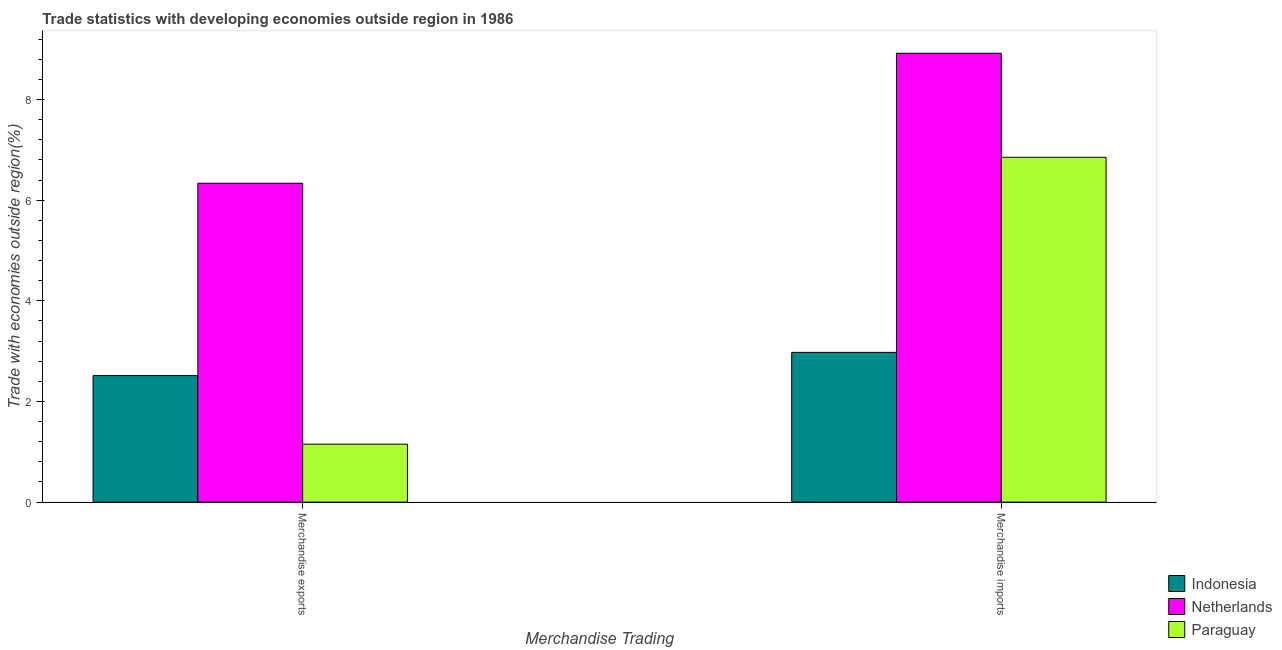How many different coloured bars are there?
Provide a succinct answer. 3. How many groups of bars are there?
Provide a succinct answer. 2. Are the number of bars on each tick of the X-axis equal?
Give a very brief answer. Yes. How many bars are there on the 2nd tick from the left?
Keep it short and to the point. 3. What is the label of the 1st group of bars from the left?
Ensure brevity in your answer.  Merchandise exports. What is the merchandise exports in Paraguay?
Your response must be concise. 1.15. Across all countries, what is the maximum merchandise exports?
Offer a terse response. 6.34. Across all countries, what is the minimum merchandise imports?
Provide a short and direct response. 2.98. What is the total merchandise imports in the graph?
Give a very brief answer. 18.75. What is the difference between the merchandise imports in Paraguay and that in Indonesia?
Your answer should be compact. 3.88. What is the difference between the merchandise exports in Paraguay and the merchandise imports in Indonesia?
Keep it short and to the point. -1.82. What is the average merchandise exports per country?
Make the answer very short. 3.33. What is the difference between the merchandise imports and merchandise exports in Indonesia?
Keep it short and to the point. 0.46. What is the ratio of the merchandise imports in Paraguay to that in Netherlands?
Your answer should be very brief. 0.77. Is the merchandise exports in Netherlands less than that in Paraguay?
Offer a very short reply. No. What does the 3rd bar from the left in Merchandise exports represents?
Keep it short and to the point. Paraguay. What does the 3rd bar from the right in Merchandise imports represents?
Provide a succinct answer. Indonesia. Are all the bars in the graph horizontal?
Provide a succinct answer. No. Does the graph contain any zero values?
Your answer should be compact. No. Where does the legend appear in the graph?
Make the answer very short. Bottom right. What is the title of the graph?
Provide a succinct answer. Trade statistics with developing economies outside region in 1986. What is the label or title of the X-axis?
Provide a short and direct response. Merchandise Trading. What is the label or title of the Y-axis?
Your answer should be very brief. Trade with economies outside region(%). What is the Trade with economies outside region(%) of Indonesia in Merchandise exports?
Make the answer very short. 2.51. What is the Trade with economies outside region(%) in Netherlands in Merchandise exports?
Your response must be concise. 6.34. What is the Trade with economies outside region(%) in Paraguay in Merchandise exports?
Make the answer very short. 1.15. What is the Trade with economies outside region(%) of Indonesia in Merchandise imports?
Keep it short and to the point. 2.98. What is the Trade with economies outside region(%) of Netherlands in Merchandise imports?
Provide a short and direct response. 8.92. What is the Trade with economies outside region(%) of Paraguay in Merchandise imports?
Ensure brevity in your answer.  6.85. Across all Merchandise Trading, what is the maximum Trade with economies outside region(%) of Indonesia?
Your answer should be compact. 2.98. Across all Merchandise Trading, what is the maximum Trade with economies outside region(%) of Netherlands?
Offer a very short reply. 8.92. Across all Merchandise Trading, what is the maximum Trade with economies outside region(%) in Paraguay?
Ensure brevity in your answer.  6.85. Across all Merchandise Trading, what is the minimum Trade with economies outside region(%) of Indonesia?
Offer a terse response. 2.51. Across all Merchandise Trading, what is the minimum Trade with economies outside region(%) in Netherlands?
Keep it short and to the point. 6.34. Across all Merchandise Trading, what is the minimum Trade with economies outside region(%) of Paraguay?
Provide a short and direct response. 1.15. What is the total Trade with economies outside region(%) in Indonesia in the graph?
Provide a short and direct response. 5.49. What is the total Trade with economies outside region(%) in Netherlands in the graph?
Your answer should be compact. 15.25. What is the total Trade with economies outside region(%) of Paraguay in the graph?
Make the answer very short. 8. What is the difference between the Trade with economies outside region(%) in Indonesia in Merchandise exports and that in Merchandise imports?
Keep it short and to the point. -0.46. What is the difference between the Trade with economies outside region(%) of Netherlands in Merchandise exports and that in Merchandise imports?
Keep it short and to the point. -2.58. What is the difference between the Trade with economies outside region(%) of Paraguay in Merchandise exports and that in Merchandise imports?
Provide a succinct answer. -5.7. What is the difference between the Trade with economies outside region(%) in Indonesia in Merchandise exports and the Trade with economies outside region(%) in Netherlands in Merchandise imports?
Ensure brevity in your answer.  -6.4. What is the difference between the Trade with economies outside region(%) in Indonesia in Merchandise exports and the Trade with economies outside region(%) in Paraguay in Merchandise imports?
Your answer should be very brief. -4.34. What is the difference between the Trade with economies outside region(%) of Netherlands in Merchandise exports and the Trade with economies outside region(%) of Paraguay in Merchandise imports?
Make the answer very short. -0.52. What is the average Trade with economies outside region(%) in Indonesia per Merchandise Trading?
Make the answer very short. 2.74. What is the average Trade with economies outside region(%) of Netherlands per Merchandise Trading?
Your answer should be very brief. 7.63. What is the average Trade with economies outside region(%) in Paraguay per Merchandise Trading?
Ensure brevity in your answer.  4. What is the difference between the Trade with economies outside region(%) in Indonesia and Trade with economies outside region(%) in Netherlands in Merchandise exports?
Keep it short and to the point. -3.82. What is the difference between the Trade with economies outside region(%) of Indonesia and Trade with economies outside region(%) of Paraguay in Merchandise exports?
Make the answer very short. 1.36. What is the difference between the Trade with economies outside region(%) of Netherlands and Trade with economies outside region(%) of Paraguay in Merchandise exports?
Give a very brief answer. 5.18. What is the difference between the Trade with economies outside region(%) of Indonesia and Trade with economies outside region(%) of Netherlands in Merchandise imports?
Your response must be concise. -5.94. What is the difference between the Trade with economies outside region(%) in Indonesia and Trade with economies outside region(%) in Paraguay in Merchandise imports?
Provide a short and direct response. -3.88. What is the difference between the Trade with economies outside region(%) of Netherlands and Trade with economies outside region(%) of Paraguay in Merchandise imports?
Provide a short and direct response. 2.07. What is the ratio of the Trade with economies outside region(%) of Indonesia in Merchandise exports to that in Merchandise imports?
Keep it short and to the point. 0.84. What is the ratio of the Trade with economies outside region(%) in Netherlands in Merchandise exports to that in Merchandise imports?
Your response must be concise. 0.71. What is the ratio of the Trade with economies outside region(%) in Paraguay in Merchandise exports to that in Merchandise imports?
Your response must be concise. 0.17. What is the difference between the highest and the second highest Trade with economies outside region(%) of Indonesia?
Offer a very short reply. 0.46. What is the difference between the highest and the second highest Trade with economies outside region(%) of Netherlands?
Provide a short and direct response. 2.58. What is the difference between the highest and the second highest Trade with economies outside region(%) of Paraguay?
Ensure brevity in your answer.  5.7. What is the difference between the highest and the lowest Trade with economies outside region(%) of Indonesia?
Offer a terse response. 0.46. What is the difference between the highest and the lowest Trade with economies outside region(%) in Netherlands?
Provide a short and direct response. 2.58. What is the difference between the highest and the lowest Trade with economies outside region(%) in Paraguay?
Offer a terse response. 5.7. 